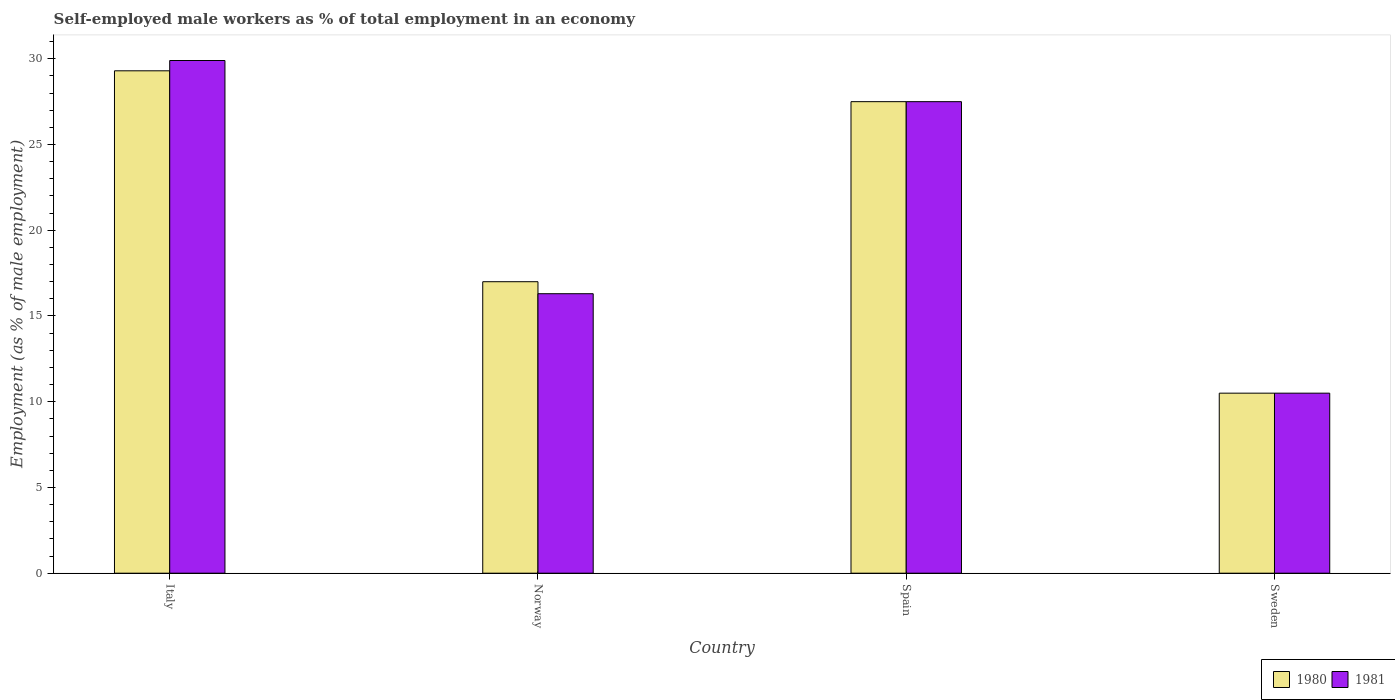How many different coloured bars are there?
Offer a very short reply. 2. How many groups of bars are there?
Your response must be concise. 4. How many bars are there on the 3rd tick from the left?
Your response must be concise. 2. How many bars are there on the 2nd tick from the right?
Provide a succinct answer. 2. What is the percentage of self-employed male workers in 1981 in Italy?
Offer a terse response. 29.9. Across all countries, what is the maximum percentage of self-employed male workers in 1981?
Keep it short and to the point. 29.9. Across all countries, what is the minimum percentage of self-employed male workers in 1981?
Provide a succinct answer. 10.5. In which country was the percentage of self-employed male workers in 1980 maximum?
Your response must be concise. Italy. In which country was the percentage of self-employed male workers in 1980 minimum?
Your answer should be very brief. Sweden. What is the total percentage of self-employed male workers in 1980 in the graph?
Provide a short and direct response. 84.3. What is the difference between the percentage of self-employed male workers in 1980 in Norway and that in Sweden?
Make the answer very short. 6.5. What is the difference between the percentage of self-employed male workers in 1980 in Sweden and the percentage of self-employed male workers in 1981 in Norway?
Keep it short and to the point. -5.8. What is the average percentage of self-employed male workers in 1981 per country?
Offer a terse response. 21.05. What is the difference between the percentage of self-employed male workers of/in 1980 and percentage of self-employed male workers of/in 1981 in Norway?
Your answer should be compact. 0.7. In how many countries, is the percentage of self-employed male workers in 1980 greater than 4 %?
Offer a very short reply. 4. What is the ratio of the percentage of self-employed male workers in 1980 in Spain to that in Sweden?
Offer a terse response. 2.62. Is the difference between the percentage of self-employed male workers in 1980 in Norway and Spain greater than the difference between the percentage of self-employed male workers in 1981 in Norway and Spain?
Give a very brief answer. Yes. What is the difference between the highest and the second highest percentage of self-employed male workers in 1980?
Provide a succinct answer. -10.5. What is the difference between the highest and the lowest percentage of self-employed male workers in 1980?
Your answer should be compact. 18.8. Is the sum of the percentage of self-employed male workers in 1980 in Italy and Spain greater than the maximum percentage of self-employed male workers in 1981 across all countries?
Provide a short and direct response. Yes. What does the 1st bar from the left in Norway represents?
Keep it short and to the point. 1980. Are the values on the major ticks of Y-axis written in scientific E-notation?
Offer a terse response. No. Does the graph contain any zero values?
Provide a short and direct response. No. Where does the legend appear in the graph?
Give a very brief answer. Bottom right. What is the title of the graph?
Your response must be concise. Self-employed male workers as % of total employment in an economy. Does "2015" appear as one of the legend labels in the graph?
Your answer should be compact. No. What is the label or title of the X-axis?
Provide a short and direct response. Country. What is the label or title of the Y-axis?
Give a very brief answer. Employment (as % of male employment). What is the Employment (as % of male employment) in 1980 in Italy?
Give a very brief answer. 29.3. What is the Employment (as % of male employment) in 1981 in Italy?
Provide a short and direct response. 29.9. What is the Employment (as % of male employment) of 1981 in Norway?
Provide a short and direct response. 16.3. What is the Employment (as % of male employment) of 1980 in Spain?
Your answer should be compact. 27.5. Across all countries, what is the maximum Employment (as % of male employment) in 1980?
Make the answer very short. 29.3. Across all countries, what is the maximum Employment (as % of male employment) in 1981?
Your answer should be very brief. 29.9. What is the total Employment (as % of male employment) in 1980 in the graph?
Provide a succinct answer. 84.3. What is the total Employment (as % of male employment) of 1981 in the graph?
Your response must be concise. 84.2. What is the difference between the Employment (as % of male employment) in 1981 in Italy and that in Spain?
Provide a succinct answer. 2.4. What is the difference between the Employment (as % of male employment) of 1980 in Norway and that in Sweden?
Offer a terse response. 6.5. What is the difference between the Employment (as % of male employment) in 1980 in Spain and that in Sweden?
Give a very brief answer. 17. What is the difference between the Employment (as % of male employment) in 1980 in Italy and the Employment (as % of male employment) in 1981 in Norway?
Your response must be concise. 13. What is the difference between the Employment (as % of male employment) in 1980 in Italy and the Employment (as % of male employment) in 1981 in Spain?
Provide a short and direct response. 1.8. What is the difference between the Employment (as % of male employment) of 1980 in Italy and the Employment (as % of male employment) of 1981 in Sweden?
Make the answer very short. 18.8. What is the difference between the Employment (as % of male employment) in 1980 in Norway and the Employment (as % of male employment) in 1981 in Spain?
Your answer should be compact. -10.5. What is the difference between the Employment (as % of male employment) in 1980 in Norway and the Employment (as % of male employment) in 1981 in Sweden?
Provide a short and direct response. 6.5. What is the difference between the Employment (as % of male employment) of 1980 in Spain and the Employment (as % of male employment) of 1981 in Sweden?
Your response must be concise. 17. What is the average Employment (as % of male employment) of 1980 per country?
Offer a terse response. 21.07. What is the average Employment (as % of male employment) of 1981 per country?
Keep it short and to the point. 21.05. What is the ratio of the Employment (as % of male employment) in 1980 in Italy to that in Norway?
Give a very brief answer. 1.72. What is the ratio of the Employment (as % of male employment) in 1981 in Italy to that in Norway?
Provide a succinct answer. 1.83. What is the ratio of the Employment (as % of male employment) in 1980 in Italy to that in Spain?
Your response must be concise. 1.07. What is the ratio of the Employment (as % of male employment) of 1981 in Italy to that in Spain?
Your answer should be very brief. 1.09. What is the ratio of the Employment (as % of male employment) in 1980 in Italy to that in Sweden?
Your answer should be compact. 2.79. What is the ratio of the Employment (as % of male employment) of 1981 in Italy to that in Sweden?
Offer a terse response. 2.85. What is the ratio of the Employment (as % of male employment) of 1980 in Norway to that in Spain?
Provide a short and direct response. 0.62. What is the ratio of the Employment (as % of male employment) in 1981 in Norway to that in Spain?
Give a very brief answer. 0.59. What is the ratio of the Employment (as % of male employment) of 1980 in Norway to that in Sweden?
Your answer should be compact. 1.62. What is the ratio of the Employment (as % of male employment) in 1981 in Norway to that in Sweden?
Your answer should be compact. 1.55. What is the ratio of the Employment (as % of male employment) in 1980 in Spain to that in Sweden?
Your answer should be compact. 2.62. What is the ratio of the Employment (as % of male employment) of 1981 in Spain to that in Sweden?
Provide a short and direct response. 2.62. What is the difference between the highest and the second highest Employment (as % of male employment) of 1980?
Give a very brief answer. 1.8. What is the difference between the highest and the lowest Employment (as % of male employment) of 1980?
Ensure brevity in your answer.  18.8. 